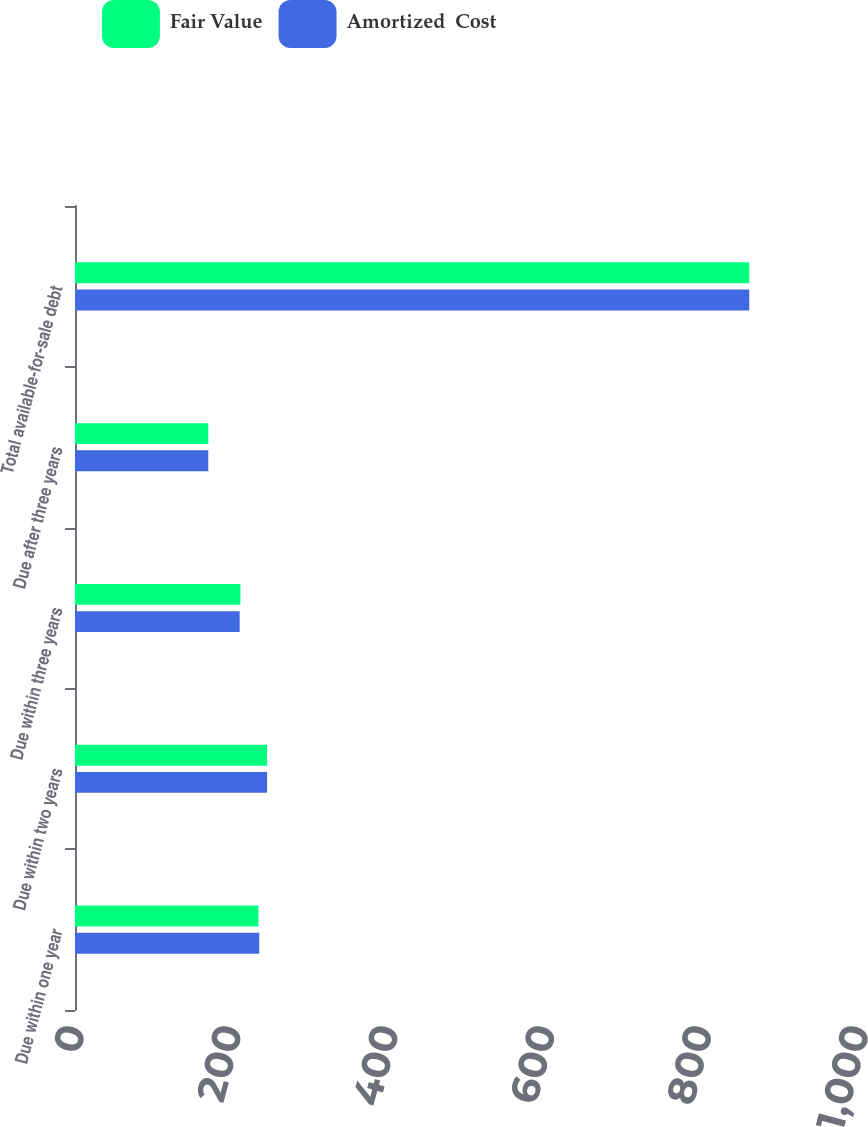Convert chart to OTSL. <chart><loc_0><loc_0><loc_500><loc_500><stacked_bar_chart><ecel><fcel>Due within one year<fcel>Due within two years<fcel>Due within three years<fcel>Due after three years<fcel>Total available-for-sale debt<nl><fcel>Fair Value<fcel>234<fcel>245<fcel>211<fcel>170<fcel>860<nl><fcel>Amortized  Cost<fcel>235<fcel>245<fcel>210<fcel>170<fcel>860<nl></chart> 